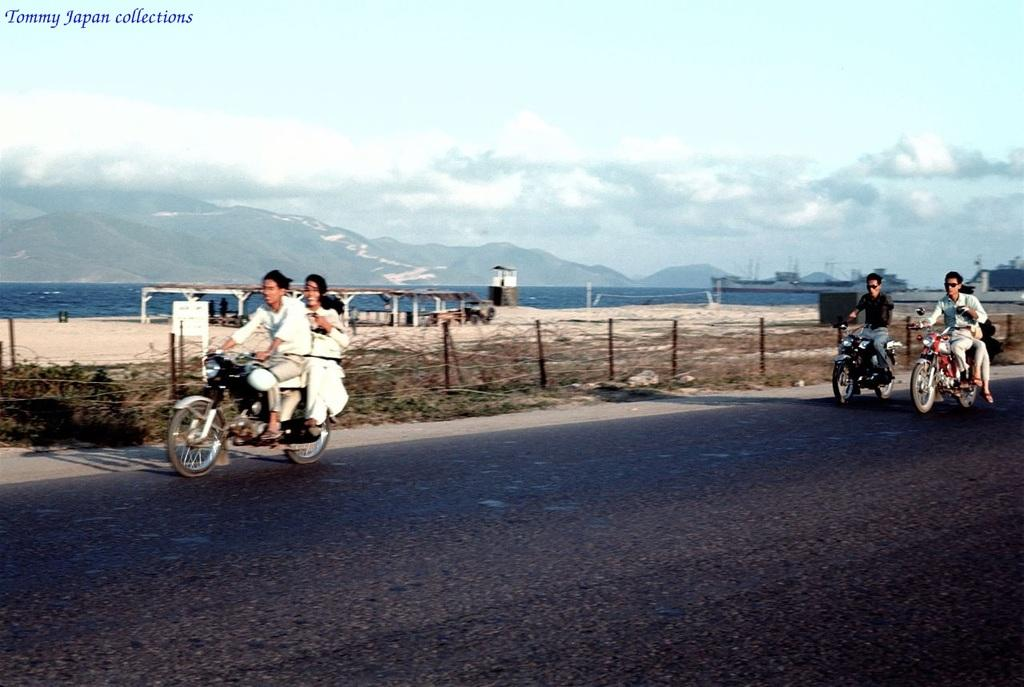What can be seen in the background of the image? There is a sky in the image. What type of landscape is visible in the image? There are hills in the image. What natural element is present in the image? There is water visible in the image. What man-made structure is present in the image? There is a road in the image. What vehicles are on the road in the image? There are motorcycles on the road. Who is riding the motorcycles in the image? There are people sitting on the motorcycles. Where is the bottle of ice placed in the image? There is no bottle of ice present in the image. 